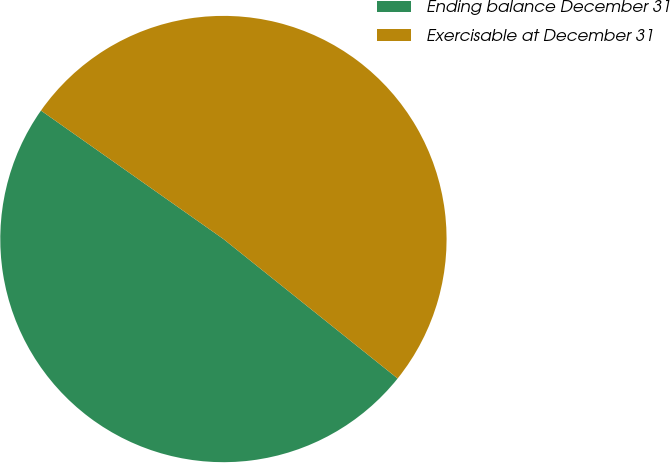<chart> <loc_0><loc_0><loc_500><loc_500><pie_chart><fcel>Ending balance December 31<fcel>Exercisable at December 31<nl><fcel>49.02%<fcel>50.98%<nl></chart> 